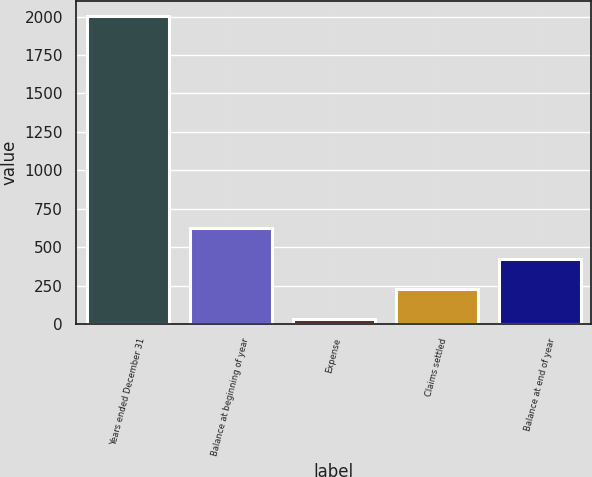Convert chart to OTSL. <chart><loc_0><loc_0><loc_500><loc_500><bar_chart><fcel>Years ended December 31<fcel>Balance at beginning of year<fcel>Expense<fcel>Claims settled<fcel>Balance at end of year<nl><fcel>2004<fcel>622.83<fcel>30.9<fcel>228.21<fcel>425.52<nl></chart> 